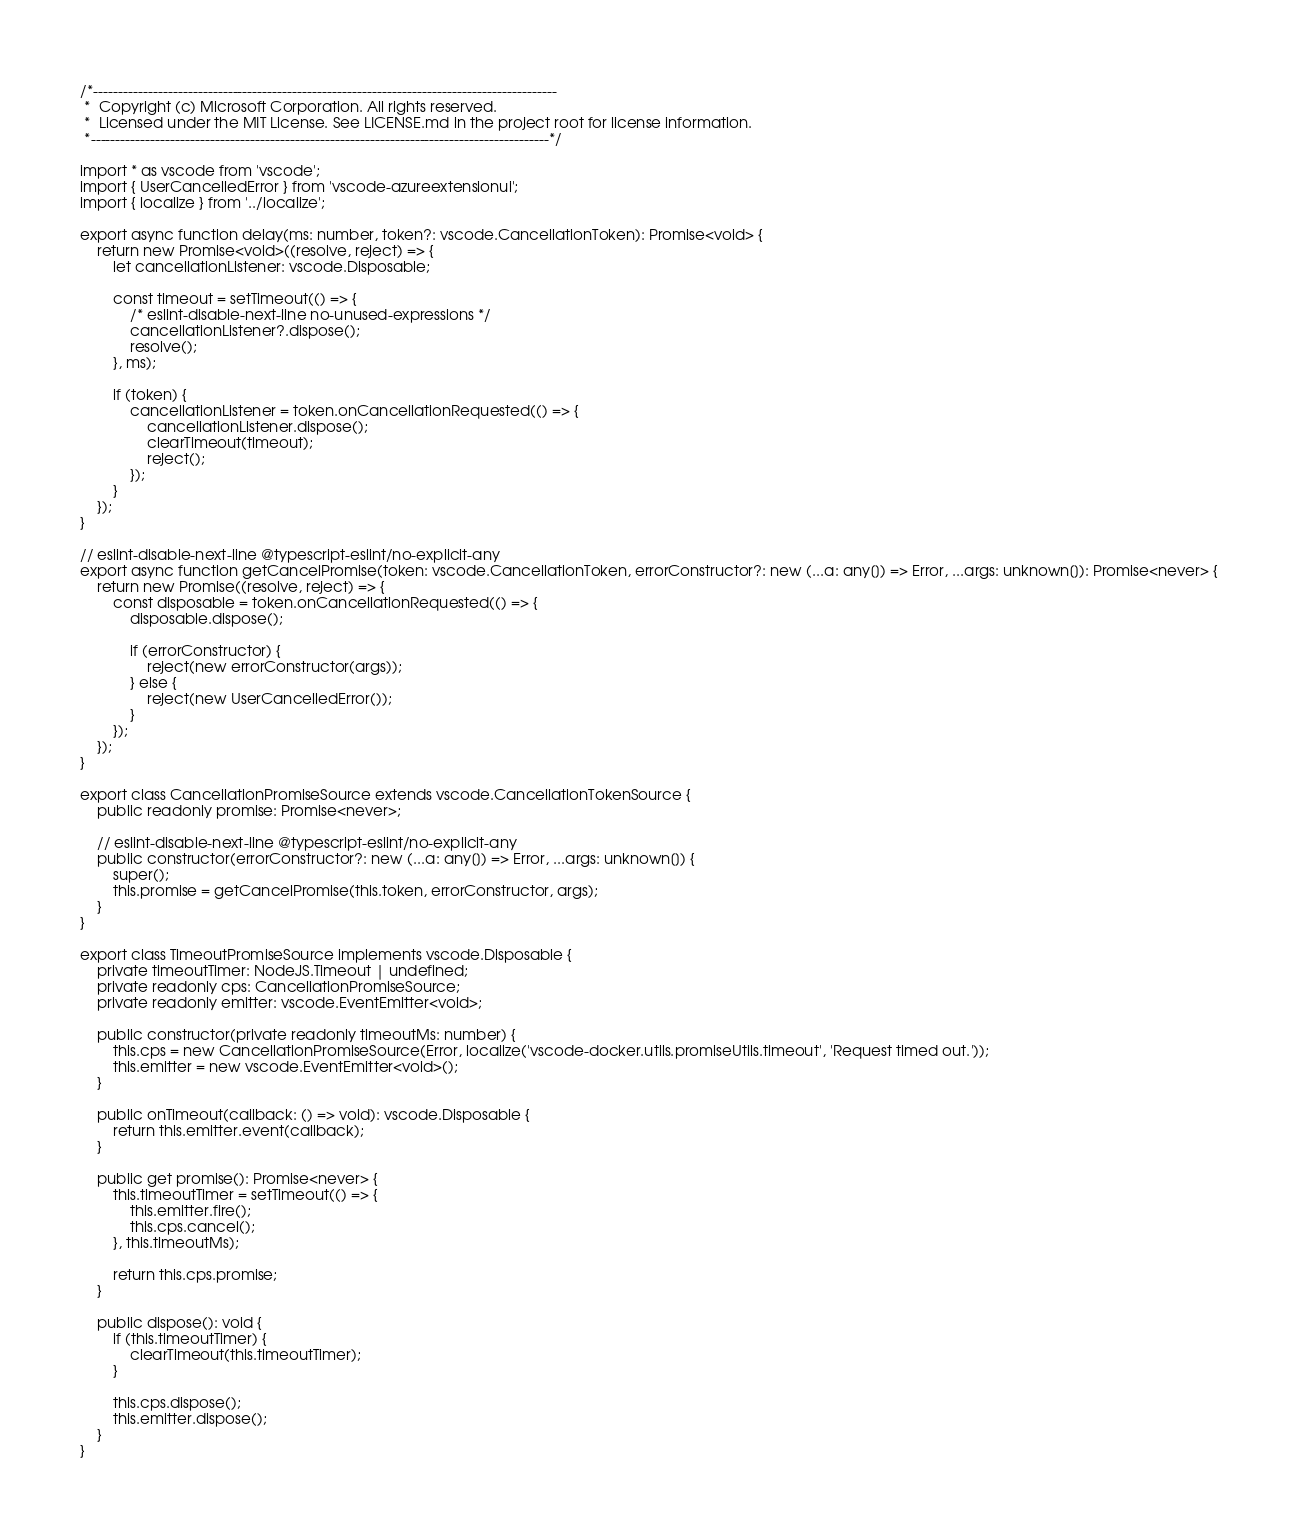<code> <loc_0><loc_0><loc_500><loc_500><_TypeScript_>/*---------------------------------------------------------------------------------------------
 *  Copyright (c) Microsoft Corporation. All rights reserved.
 *  Licensed under the MIT License. See LICENSE.md in the project root for license information.
 *--------------------------------------------------------------------------------------------*/

import * as vscode from 'vscode';
import { UserCancelledError } from 'vscode-azureextensionui';
import { localize } from '../localize';

export async function delay(ms: number, token?: vscode.CancellationToken): Promise<void> {
    return new Promise<void>((resolve, reject) => {
        let cancellationListener: vscode.Disposable;

        const timeout = setTimeout(() => {
            /* eslint-disable-next-line no-unused-expressions */
            cancellationListener?.dispose();
            resolve();
        }, ms);

        if (token) {
            cancellationListener = token.onCancellationRequested(() => {
                cancellationListener.dispose();
                clearTimeout(timeout);
                reject();
            });
        }
    });
}

// eslint-disable-next-line @typescript-eslint/no-explicit-any
export async function getCancelPromise(token: vscode.CancellationToken, errorConstructor?: new (...a: any[]) => Error, ...args: unknown[]): Promise<never> {
    return new Promise((resolve, reject) => {
        const disposable = token.onCancellationRequested(() => {
            disposable.dispose();

            if (errorConstructor) {
                reject(new errorConstructor(args));
            } else {
                reject(new UserCancelledError());
            }
        });
    });
}

export class CancellationPromiseSource extends vscode.CancellationTokenSource {
    public readonly promise: Promise<never>;

    // eslint-disable-next-line @typescript-eslint/no-explicit-any
    public constructor(errorConstructor?: new (...a: any[]) => Error, ...args: unknown[]) {
        super();
        this.promise = getCancelPromise(this.token, errorConstructor, args);
    }
}

export class TimeoutPromiseSource implements vscode.Disposable {
    private timeoutTimer: NodeJS.Timeout | undefined;
    private readonly cps: CancellationPromiseSource;
    private readonly emitter: vscode.EventEmitter<void>;

    public constructor(private readonly timeoutMs: number) {
        this.cps = new CancellationPromiseSource(Error, localize('vscode-docker.utils.promiseUtils.timeout', 'Request timed out.'));
        this.emitter = new vscode.EventEmitter<void>();
    }

    public onTimeout(callback: () => void): vscode.Disposable {
        return this.emitter.event(callback);
    }

    public get promise(): Promise<never> {
        this.timeoutTimer = setTimeout(() => {
            this.emitter.fire();
            this.cps.cancel();
        }, this.timeoutMs);

        return this.cps.promise;
    }

    public dispose(): void {
        if (this.timeoutTimer) {
            clearTimeout(this.timeoutTimer);
        }

        this.cps.dispose();
        this.emitter.dispose();
    }
}
</code> 